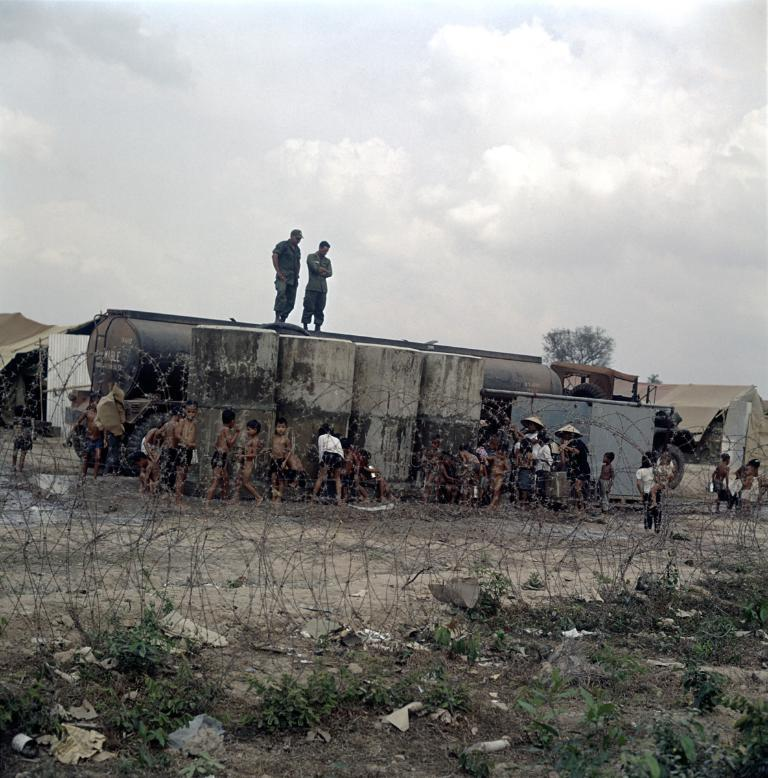What are the two people doing in the image? The two people are on containers in the image. Who else is present in the image besides the two people? There are children in the image. What can be seen in the background of the image? There is a fence, trees, a vehicle, houses, and clouds in the sky in the image. What type of quilt is being used by the people in the image? There is no quilt present in the image. What is the destination of the voyage depicted in the image? There is no voyage depicted in the image. 